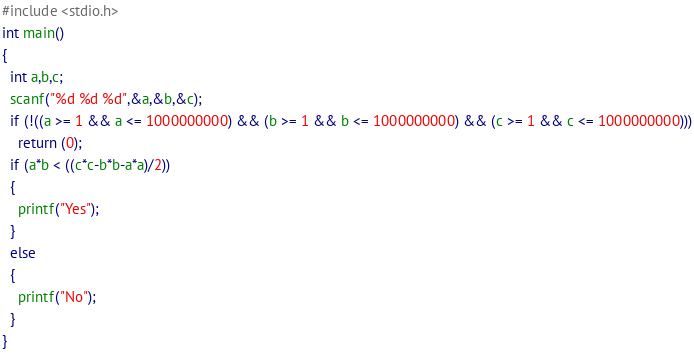Convert code to text. <code><loc_0><loc_0><loc_500><loc_500><_C_>#include <stdio.h>
int main()
{
  int a,b,c;
  scanf("%d %d %d",&a,&b,&c);
  if (!((a >= 1 && a <= 1000000000) && (b >= 1 && b <= 1000000000) && (c >= 1 && c <= 1000000000)))
    return (0);
  if (a*b < ((c*c-b*b-a*a)/2))
  {
    printf("Yes");
  }
  else
  {
    printf("No");
  }
}</code> 